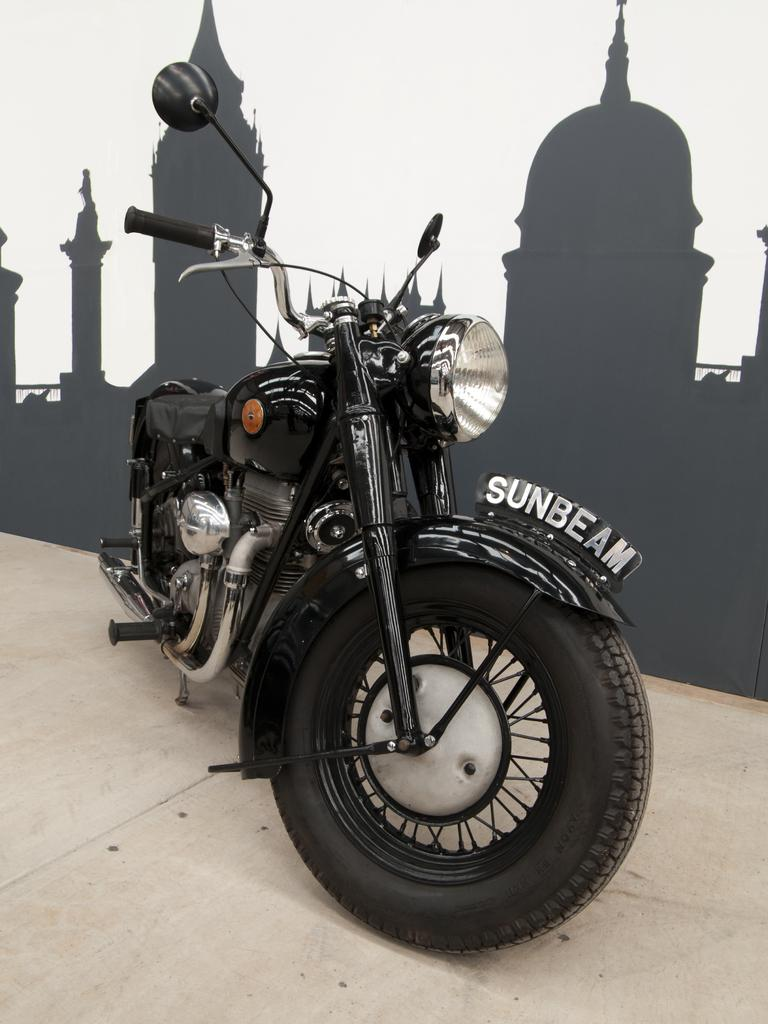What type of bike is in the image? There is a black color bike in the image. Where is the bike located in the image? The bike is on the floor. What else can be seen in the image besides the bike? There is a poster with an image in the image. What type of discussion is taking place in the image? There is no discussion taking place in the image; it only features a black color bike on the floor and a poster with an image. How many people are involved in the group activity in the image? There is no group activity present in the image; it only features a black color bike on the floor and a poster with an image. 